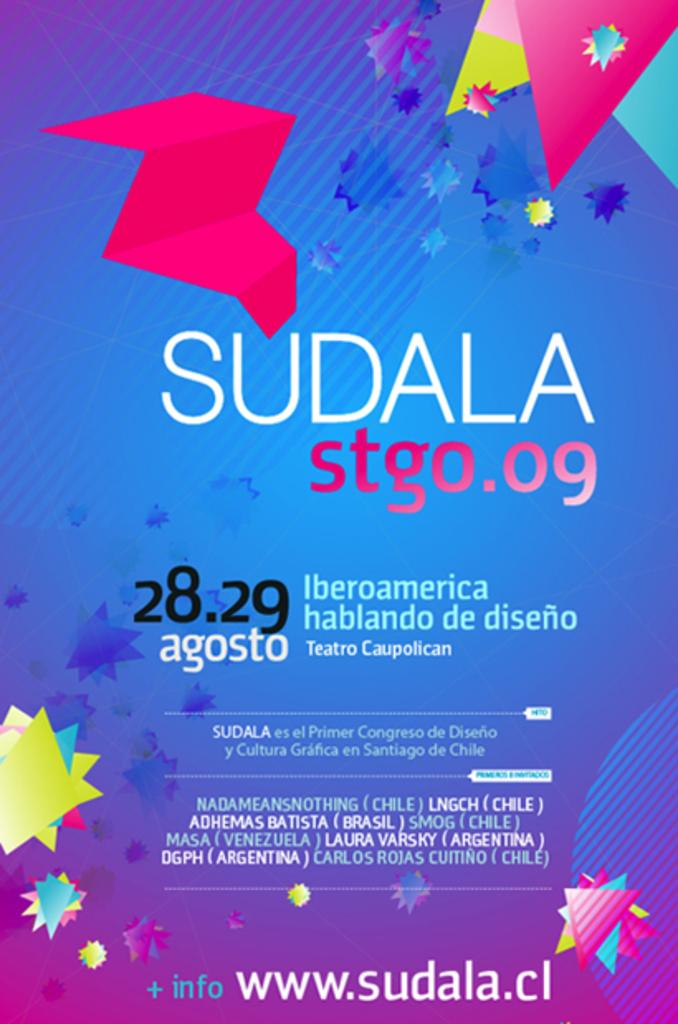<image>
Create a compact narrative representing the image presented. A poster for Sudala on the 28 and 29 agosto 